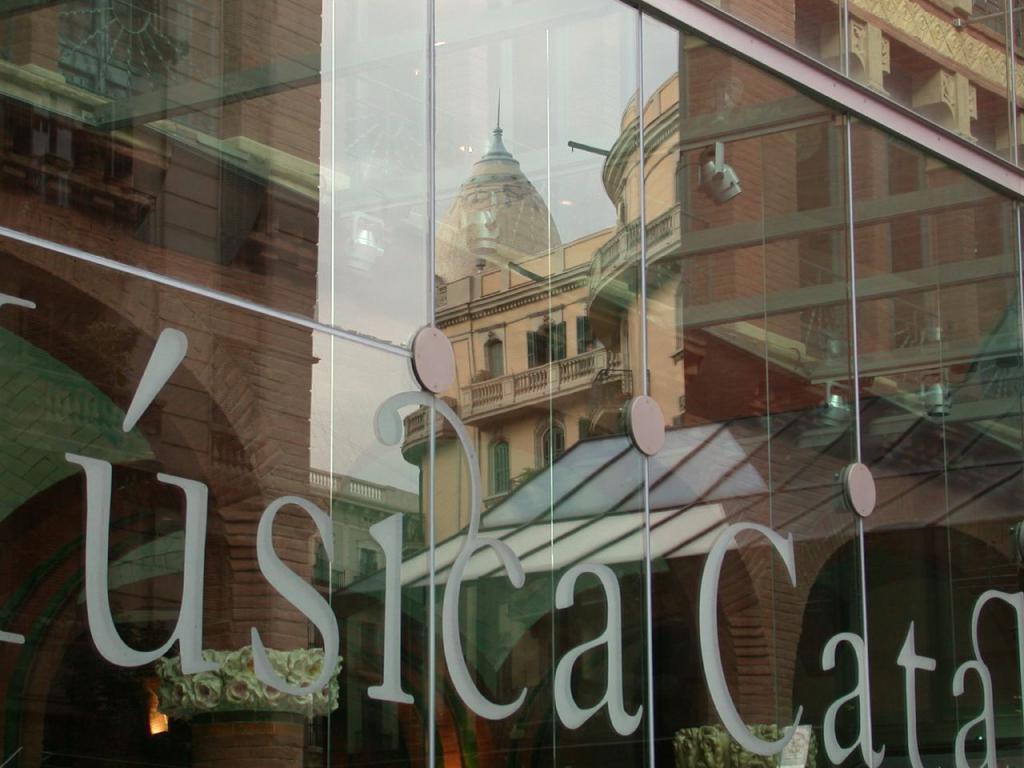Please provide a concise description of this image. In the center of the image there is a reflection of a building. At the bottom of the image there is some text. 